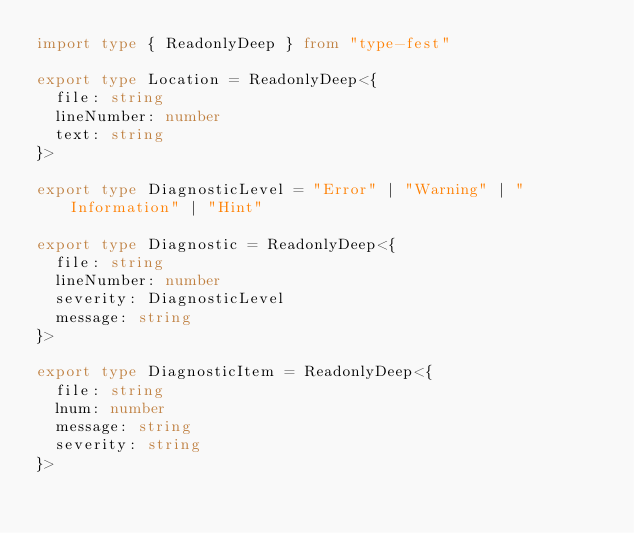Convert code to text. <code><loc_0><loc_0><loc_500><loc_500><_TypeScript_>import type { ReadonlyDeep } from "type-fest"

export type Location = ReadonlyDeep<{
  file: string
  lineNumber: number
  text: string
}>

export type DiagnosticLevel = "Error" | "Warning" | "Information" | "Hint"

export type Diagnostic = ReadonlyDeep<{
  file: string
  lineNumber: number
  severity: DiagnosticLevel
  message: string
}>

export type DiagnosticItem = ReadonlyDeep<{
  file: string
  lnum: number
  message: string
  severity: string
}>
</code> 